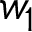Convert formula to latex. <formula><loc_0><loc_0><loc_500><loc_500>w _ { 1 }</formula> 